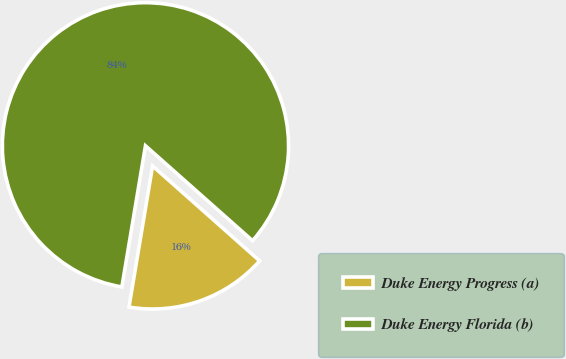<chart> <loc_0><loc_0><loc_500><loc_500><pie_chart><fcel>Duke Energy Progress (a)<fcel>Duke Energy Florida (b)<nl><fcel>16.09%<fcel>83.91%<nl></chart> 